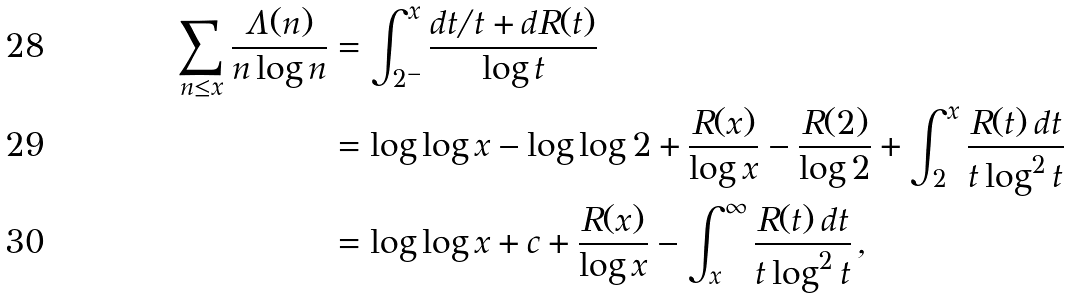Convert formula to latex. <formula><loc_0><loc_0><loc_500><loc_500>\sum _ { n \leq x } \frac { \Lambda ( n ) } { n \log n } & = \int _ { 2 ^ { - } } ^ { x } \frac { d t / t + d R ( t ) } { \log t } \\ & = \log \log x - \log \log 2 + \frac { R ( x ) } { \log x } - \frac { R ( 2 ) } { \log 2 } + \int _ { 2 } ^ { x } \frac { R ( t ) \, d t } { t \log ^ { 2 } t } \\ & = \log \log x + c + \frac { R ( x ) } { \log x } - \int _ { x } ^ { \infty } \frac { R ( t ) \, d t } { t \log ^ { 2 } t } \, ,</formula> 